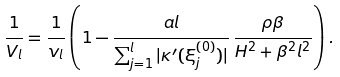<formula> <loc_0><loc_0><loc_500><loc_500>\frac { 1 } { V _ { l } } = \frac { 1 } { v _ { l } } \left ( 1 - \frac { a l } { \sum _ { j = 1 } ^ { l } | \kappa ^ { \prime } ( \xi ^ { ( 0 ) } _ { j } ) | } \, \frac { \rho \beta } { H ^ { 2 } + \beta ^ { 2 } l ^ { 2 } } \right ) .</formula> 